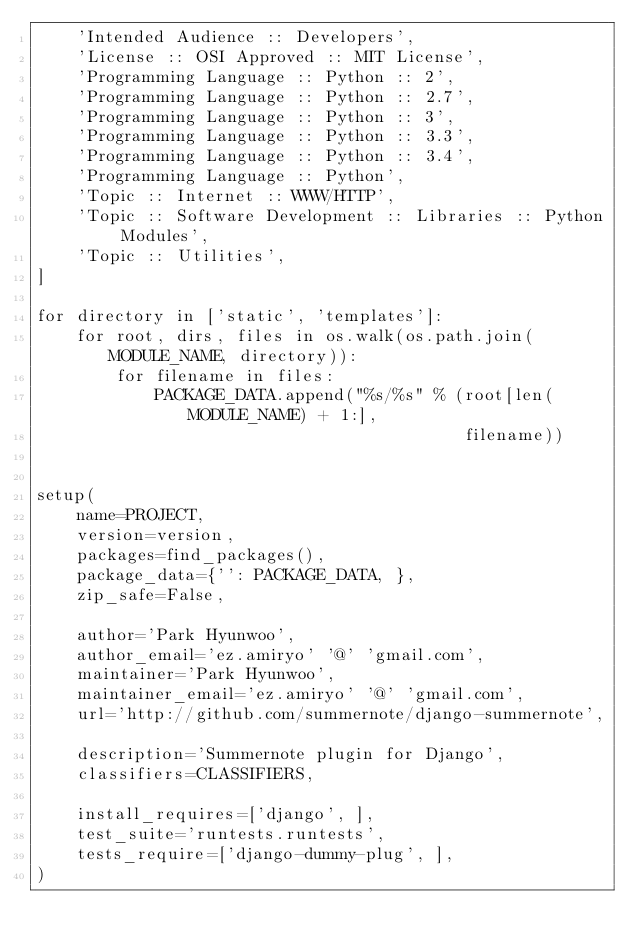Convert code to text. <code><loc_0><loc_0><loc_500><loc_500><_Python_>    'Intended Audience :: Developers',
    'License :: OSI Approved :: MIT License',
    'Programming Language :: Python :: 2',
    'Programming Language :: Python :: 2.7',
    'Programming Language :: Python :: 3',
    'Programming Language :: Python :: 3.3',
    'Programming Language :: Python :: 3.4',
    'Programming Language :: Python',
    'Topic :: Internet :: WWW/HTTP',
    'Topic :: Software Development :: Libraries :: Python Modules',
    'Topic :: Utilities',
]

for directory in ['static', 'templates']:
    for root, dirs, files in os.walk(os.path.join(MODULE_NAME, directory)):
        for filename in files:
            PACKAGE_DATA.append("%s/%s" % (root[len(MODULE_NAME) + 1:],
                                           filename))


setup(
    name=PROJECT,
    version=version,
    packages=find_packages(),
    package_data={'': PACKAGE_DATA, },
    zip_safe=False,

    author='Park Hyunwoo',
    author_email='ez.amiryo' '@' 'gmail.com',
    maintainer='Park Hyunwoo',
    maintainer_email='ez.amiryo' '@' 'gmail.com',
    url='http://github.com/summernote/django-summernote',

    description='Summernote plugin for Django',
    classifiers=CLASSIFIERS,

    install_requires=['django', ],
    test_suite='runtests.runtests',
    tests_require=['django-dummy-plug', ],
)
</code> 